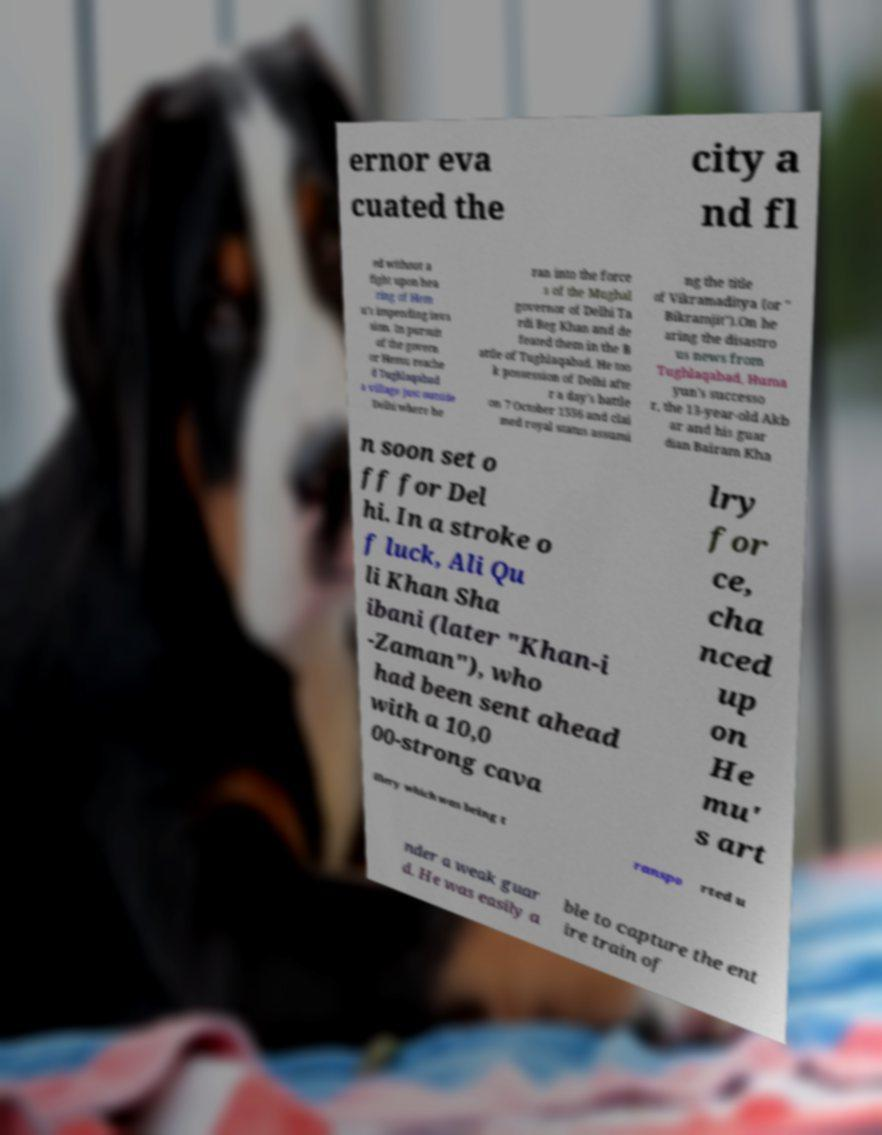Please identify and transcribe the text found in this image. ernor eva cuated the city a nd fl ed without a fight upon hea ring of Hem u's impending inva sion. In pursuit of the govern or Hemu reache d Tughlaqabad a village just outside Delhi where he ran into the force s of the Mughal governor of Delhi Ta rdi Beg Khan and de feated them in the B attle of Tughlaqabad. He too k possession of Delhi afte r a day's battle on 7 October 1556 and clai med royal status assumi ng the title of Vikramaditya (or " Bikramjit").On he aring the disastro us news from Tughlaqabad, Huma yun's successo r, the 13-year-old Akb ar and his guar dian Bairam Kha n soon set o ff for Del hi. In a stroke o f luck, Ali Qu li Khan Sha ibani (later "Khan-i -Zaman"), who had been sent ahead with a 10,0 00-strong cava lry for ce, cha nced up on He mu' s art illery which was being t ranspo rted u nder a weak guar d. He was easily a ble to capture the ent ire train of 